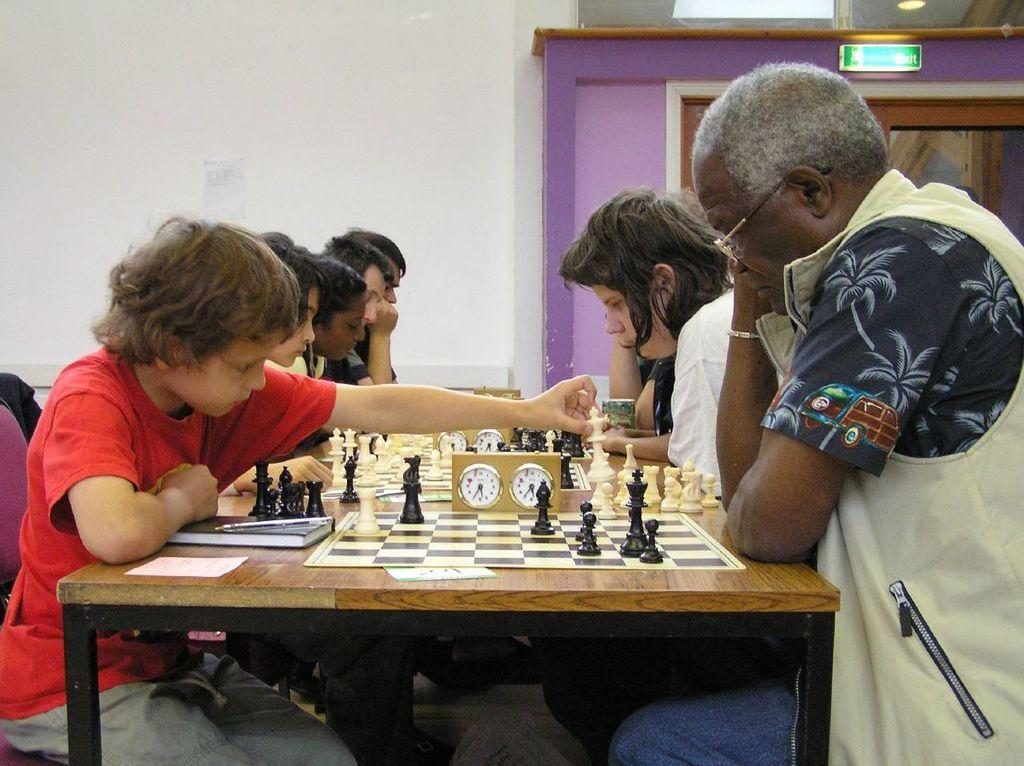What are the people in the image doing? The people in the image are sitting on chairs. What is on the table in the image? There is a chess board on the table. What type of game is being played on the chess board? Chess coins are present on the chess board, indicating that a game of chess is being played. What is the caption of the image? There is no caption present in the image. What does the cook do in the image? There is no cook present in the image. 